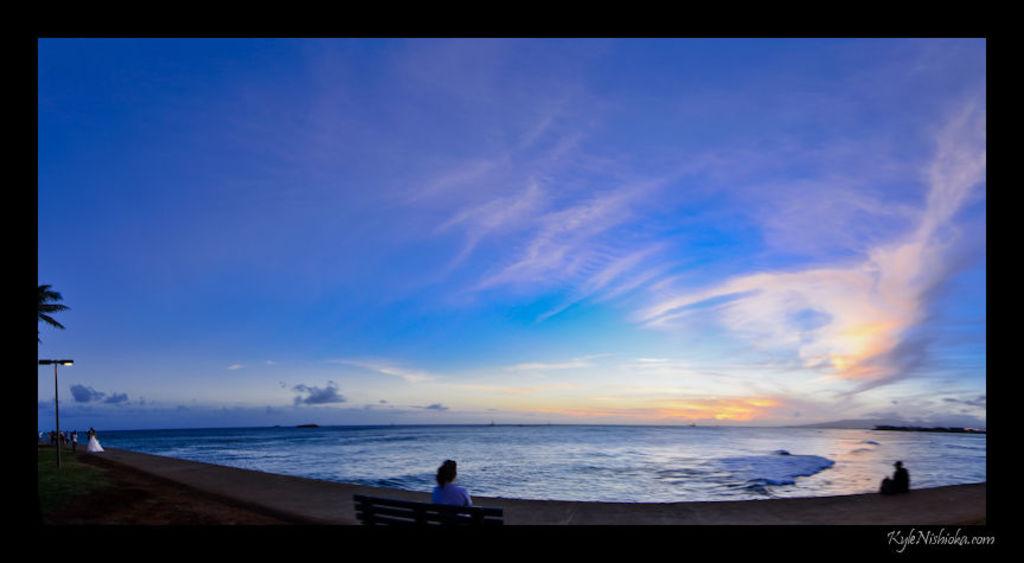Who took this photo?
Provide a succinct answer. Kyle nishioka. Where can i go to find more photos like this?
Your answer should be compact. Kylenishioka.com. 